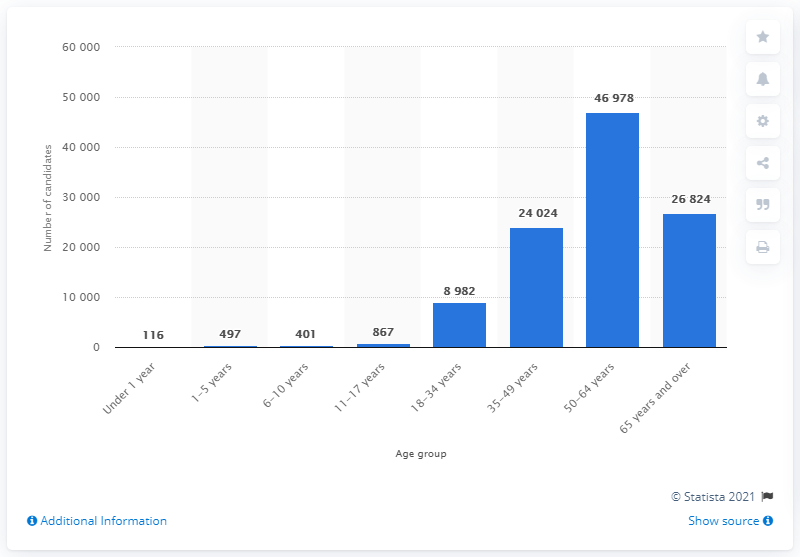Highlight a few significant elements in this photo. The age group with the largest number of individuals on the transplant waiting list in the United States in October 2020 was 50-64 years old. 